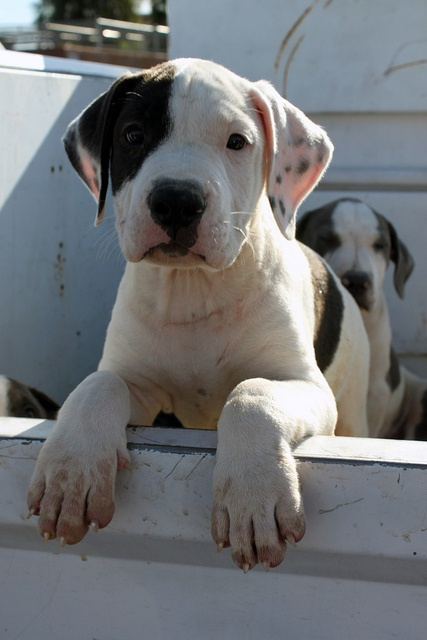Describe the objects in this image and their specific colors. I can see dog in white, gray, black, and darkgray tones and dog in white, gray, and black tones in this image. 